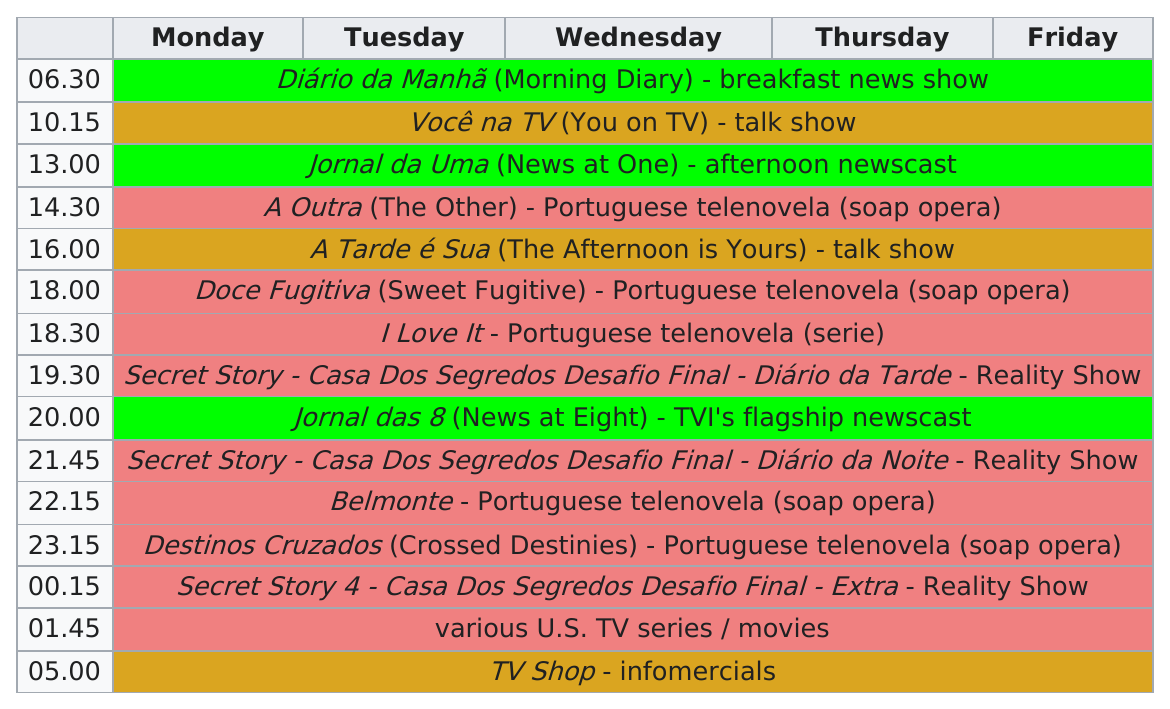Give some essential details in this illustration. The time for Belmonte to start is at 10:00 PM. I expect there to be three episodes of "Secret Story" in total. 